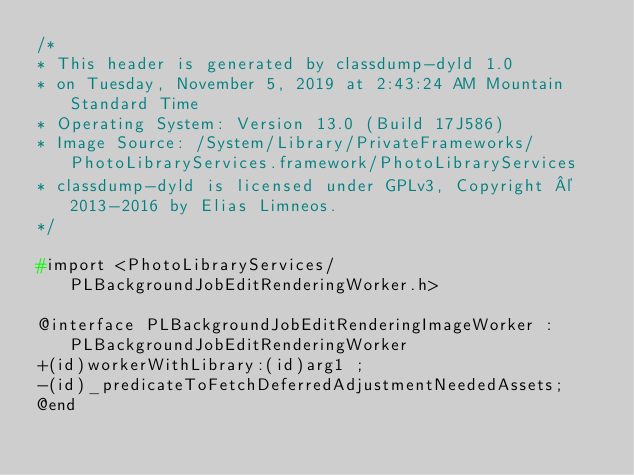<code> <loc_0><loc_0><loc_500><loc_500><_C_>/*
* This header is generated by classdump-dyld 1.0
* on Tuesday, November 5, 2019 at 2:43:24 AM Mountain Standard Time
* Operating System: Version 13.0 (Build 17J586)
* Image Source: /System/Library/PrivateFrameworks/PhotoLibraryServices.framework/PhotoLibraryServices
* classdump-dyld is licensed under GPLv3, Copyright © 2013-2016 by Elias Limneos.
*/

#import <PhotoLibraryServices/PLBackgroundJobEditRenderingWorker.h>

@interface PLBackgroundJobEditRenderingImageWorker : PLBackgroundJobEditRenderingWorker
+(id)workerWithLibrary:(id)arg1 ;
-(id)_predicateToFetchDeferredAdjustmentNeededAssets;
@end

</code> 